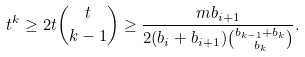Convert formula to latex. <formula><loc_0><loc_0><loc_500><loc_500>t ^ { k } \geq 2 t \binom { t } { k - 1 } \geq \frac { m b _ { i + 1 } } { 2 ( b _ { i } + b _ { i + 1 } ) \binom { b _ { k - 1 } + b _ { k } } { b _ { k } } } .</formula> 